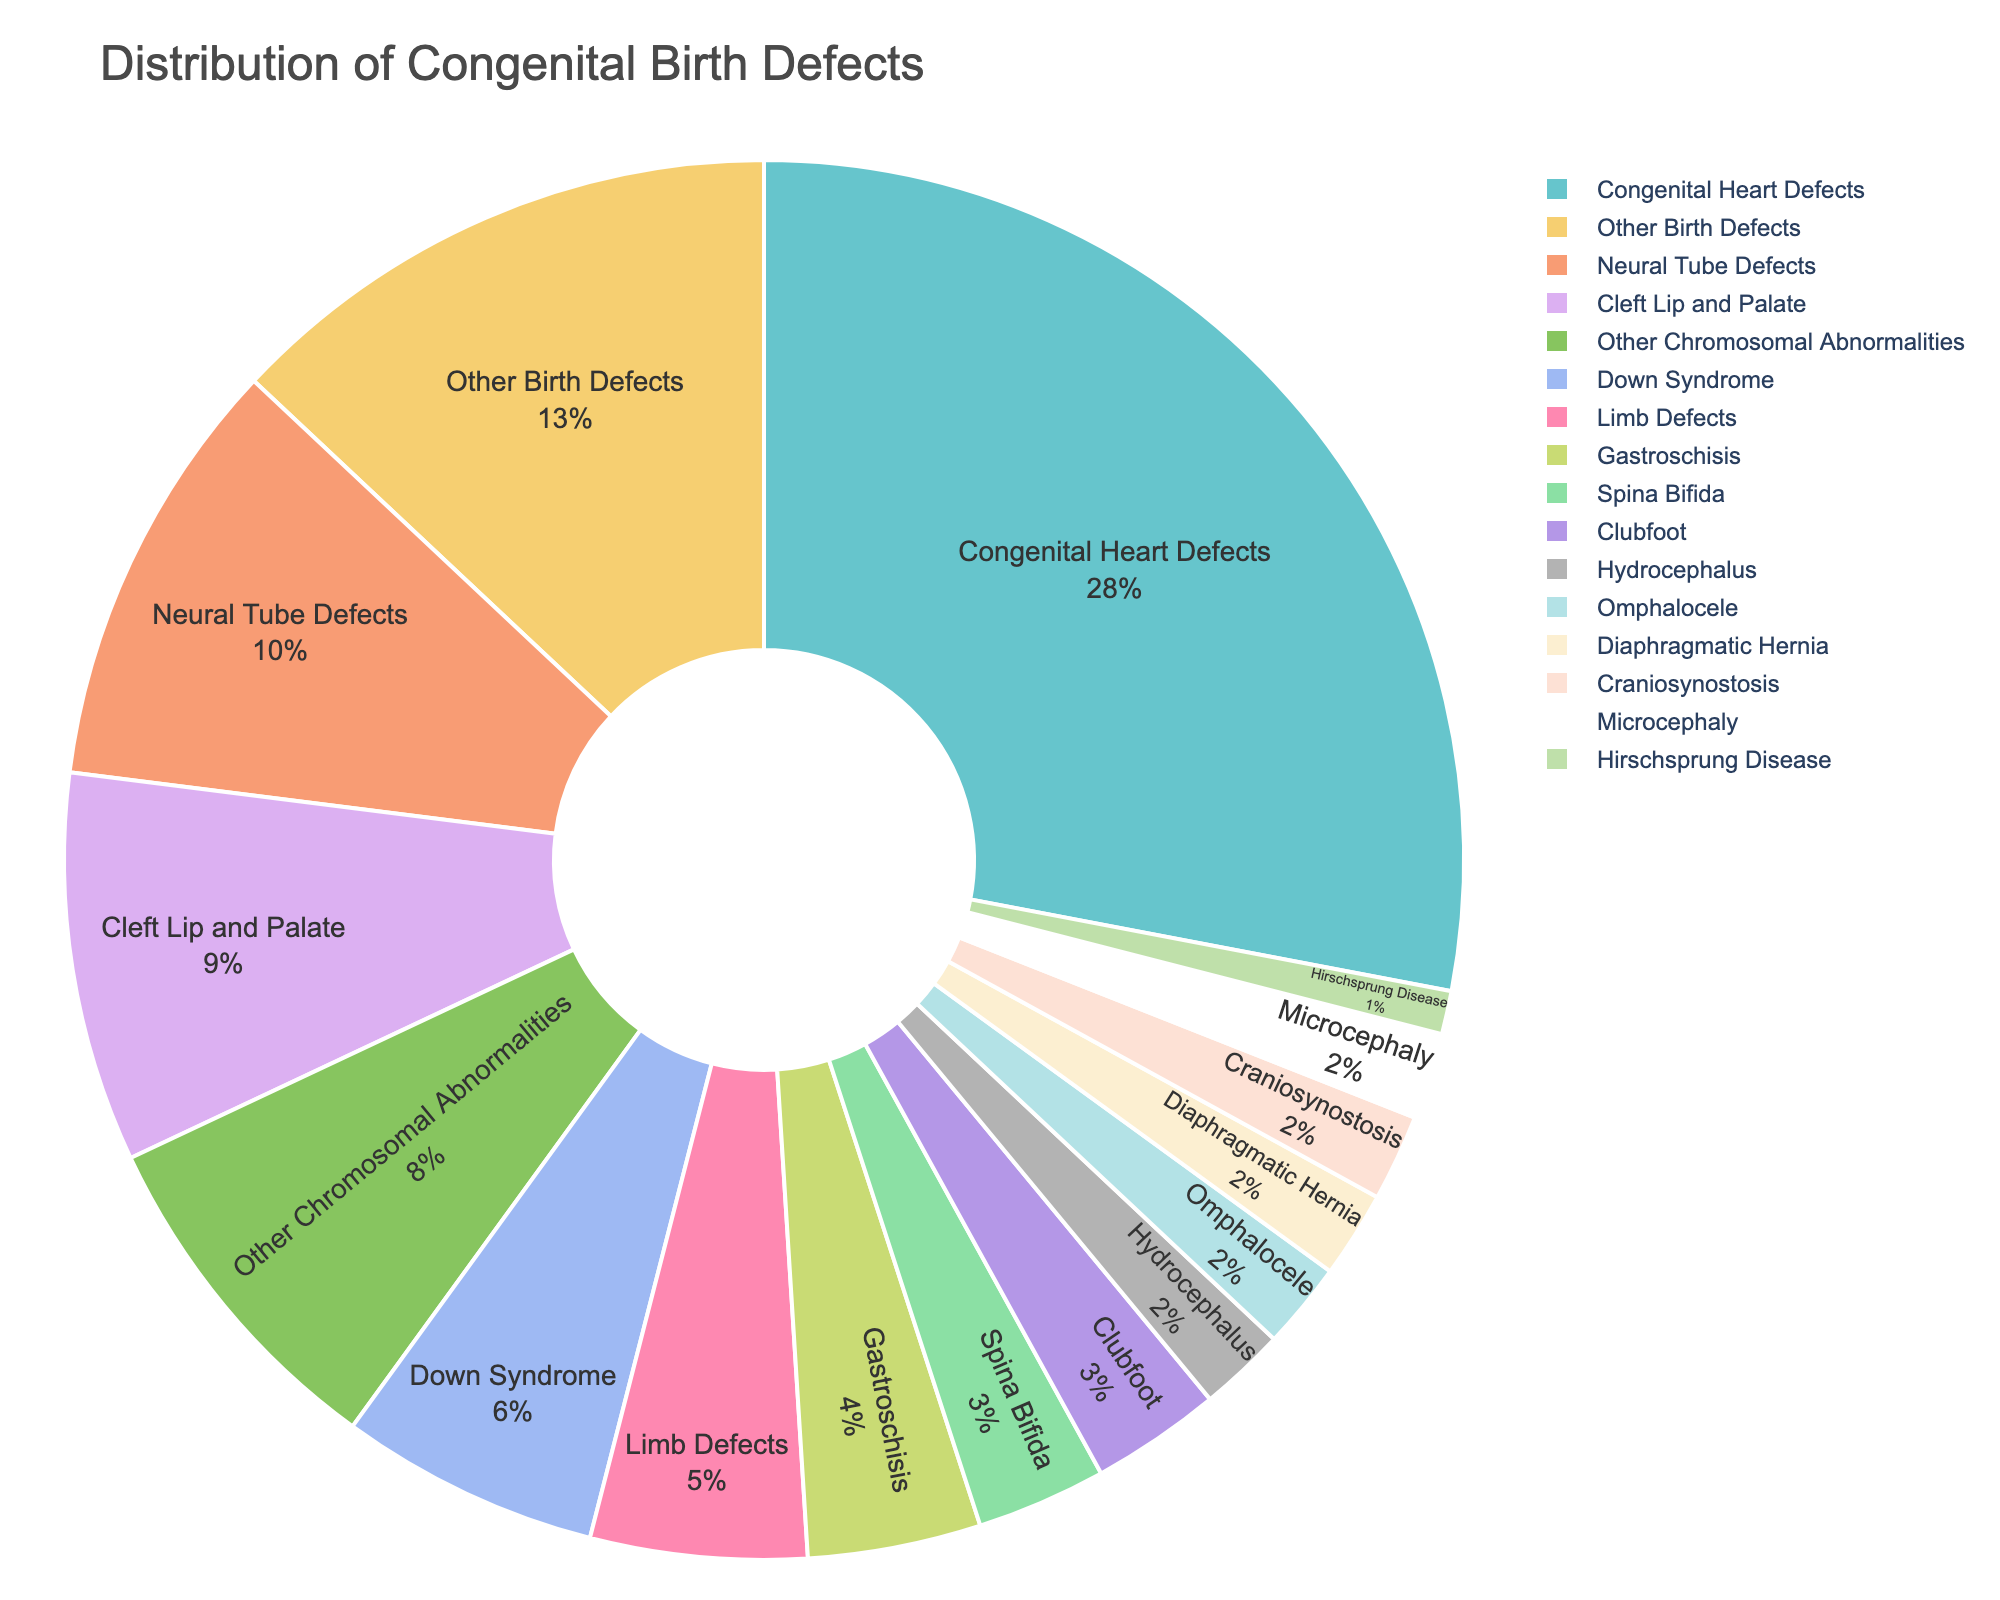What is the most common type of congenital birth defect among affected children? The most common type of congenital birth defect is the one with the largest percentage slice in the pie chart.
Answer: Congenital Heart Defects Which type of congenital birth defect accounts for the least percentage of affected children? The type of congenital birth defect with the smallest percentage in the pie chart is the least common.
Answer: Hirschsprung Disease How much more common are Congenital Heart Defects than Neural Tube Defects? To find how much more common, subtract the percentage of Neural Tube Defects from Congenital Heart Defects. Congenital Heart Defects: 28%, Neural Tube Defects: 10%. 28 - 10 = 18
Answer: 18% Which three birth defects have the lowest percentages, and what are they? Identify the three smallest percentages in the pie chart and their corresponding defect types. They are Spina Bifida (3%), Clubfoot (3%), and Hydrocephalus (2%), Omphalocele (2%), Diaphragmatic Hernia (2%), Craniosynostosis (2%), Microcephaly (2%), and Hirschsprung Disease (1%). Since there are several tied, name any three.
Answer: Spina Bifida, Clubfoot, and Hydrocephalus What is the combined percentage of Cleft Lip and Palate and Clubfoot birth defects? Add the percentages of Cleft Lip and Palate and Clubfoot birth defects. Cleft Lip and Palate: 9%, Clubfoot: 3%. 9 + 3 = 12
Answer: 12% Are there more children with Neural Tube Defects than children with Chromosomal Abnormalities? Compare the percentages of Neural Tube Defects and Other Chromosomal Abnormalities. Neural Tube Defects: 10%, Other Chromosomal Abnormalities: 8%. Since 10% > 8%, there are more children with Neural Tube Defects.
Answer: Yes Which two types of defects have exactly the same proportion and what is their combined percentage? Identify the two types of defects with the same percentage and sum them. Spina Bifida and Clubfoot both have 3%. 3 + 3 = 6.
Answer: Spina Bifida and Clubfoot, 6% What percentage of affected children have either Diaphragmatic Hernia or Microcephaly? Add the percentages of Diaphragmatic Hernia and Microcephaly. Both Diaphragmatic Hernia and Microcephaly are 2%. 2 + 2 = 4
Answer: 4% Which birth defect is represented with a light green slice, and what is its percentage? Identify the birth defect in the pie chart with a specific color slice to determine the type and its percentage.
Answer: Omphalocele, 2% What is the total percentage of children with limb-related birth defects (Limb Defects and Clubfoot)? Sum the percentages of Limb Defects and Clubfoot. Limb Defects: 5%, Clubfoot: 3%. 5 + 3 = 8
Answer: 8% 